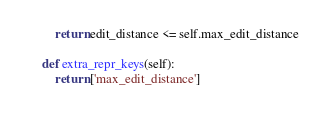Convert code to text. <code><loc_0><loc_0><loc_500><loc_500><_Python_>        return edit_distance <= self.max_edit_distance
    
    def extra_repr_keys(self):
        return ['max_edit_distance']
</code> 